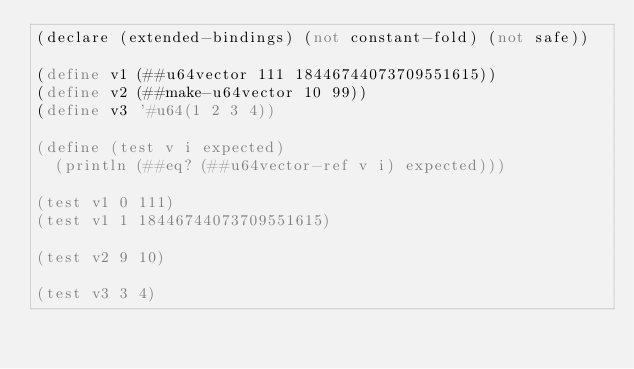Convert code to text. <code><loc_0><loc_0><loc_500><loc_500><_Scheme_>(declare (extended-bindings) (not constant-fold) (not safe))

(define v1 (##u64vector 111 18446744073709551615))
(define v2 (##make-u64vector 10 99))
(define v3 '#u64(1 2 3 4))

(define (test v i expected)
  (println (##eq? (##u64vector-ref v i) expected)))

(test v1 0 111)
(test v1 1 18446744073709551615)

(test v2 9 10)

(test v3 3 4)
</code> 